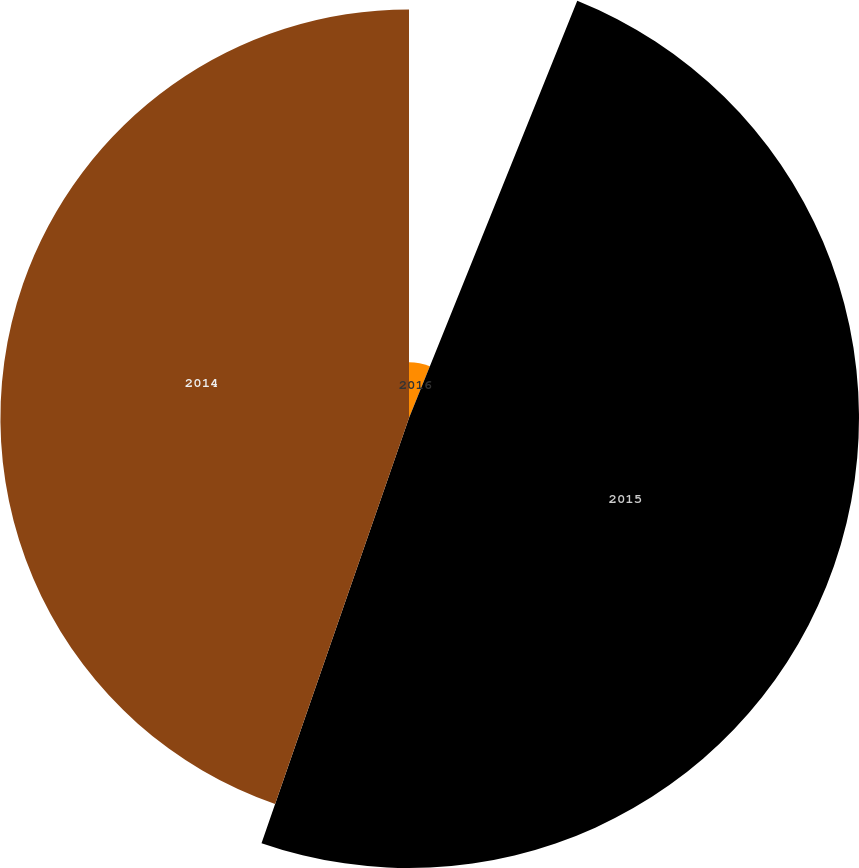<chart> <loc_0><loc_0><loc_500><loc_500><pie_chart><fcel>2016<fcel>2015<fcel>2014<nl><fcel>6.1%<fcel>49.22%<fcel>44.69%<nl></chart> 